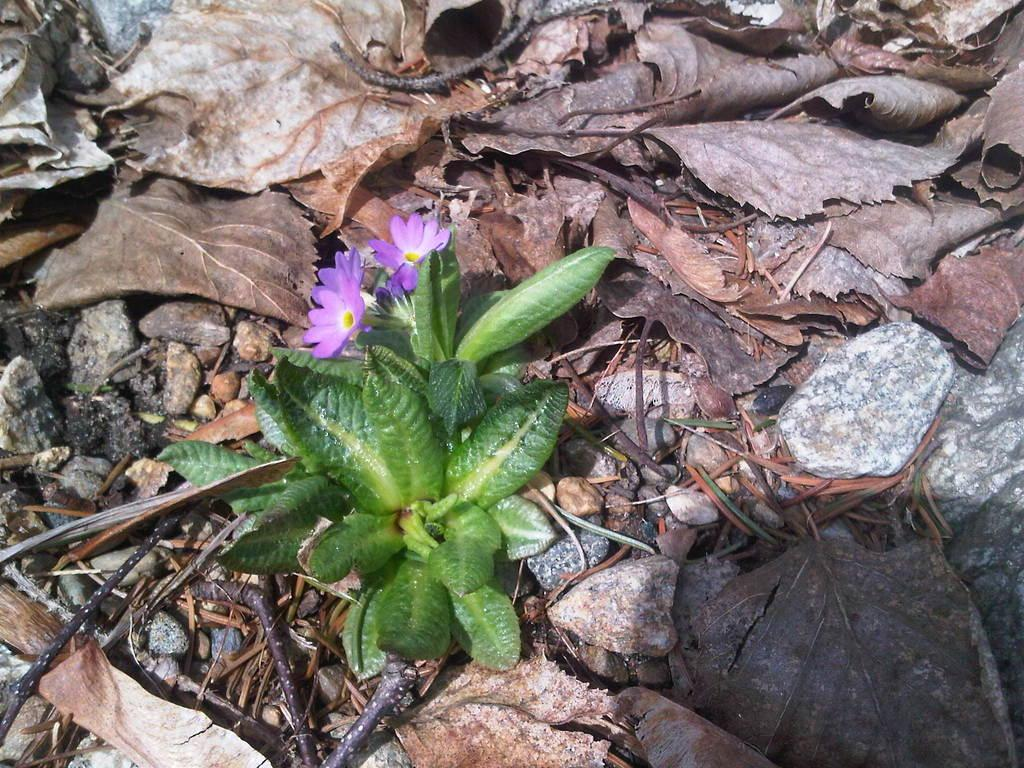What type of plant can be seen in the image? There is a plant with flowers in the image. What can be observed in the background of the image? Dry leaves and stones are visible in the background of the image. Can you describe any additional features in the image? There is a shadow in the image. How many apples are being carried by the laborer in the image? There is no laborer or apples present in the image. What type of earthquake can be seen in the image? There is no earthquake visible in the image; it is a still image of a plant, dry leaves, stones, and a shadow. 